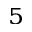Convert formula to latex. <formula><loc_0><loc_0><loc_500><loc_500>^ { 5 }</formula> 